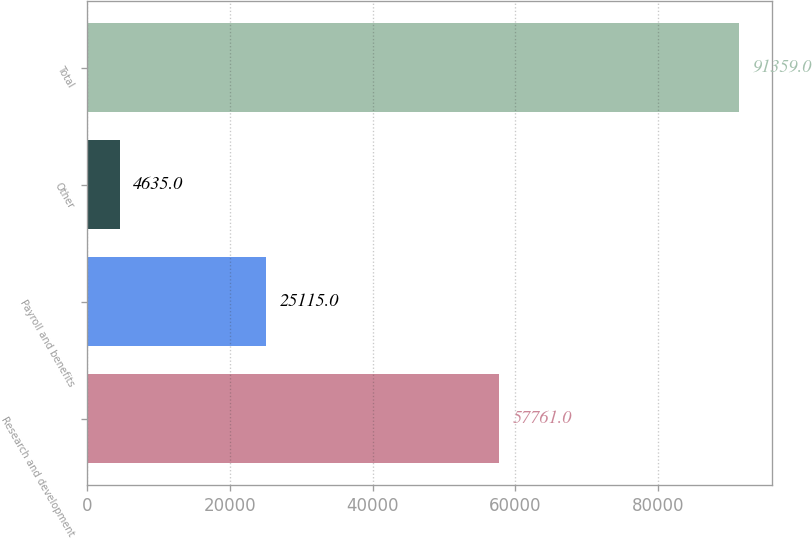Convert chart to OTSL. <chart><loc_0><loc_0><loc_500><loc_500><bar_chart><fcel>Research and development<fcel>Payroll and benefits<fcel>Other<fcel>Total<nl><fcel>57761<fcel>25115<fcel>4635<fcel>91359<nl></chart> 